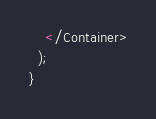Convert code to text. <code><loc_0><loc_0><loc_500><loc_500><_JavaScript_>    </Container>
  );
}
</code> 